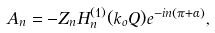<formula> <loc_0><loc_0><loc_500><loc_500>A _ { n } = - Z _ { n } H _ { n } ^ { ( 1 ) } ( k _ { o } Q ) e ^ { - i n \left ( \pi + \alpha \right ) } ,</formula> 